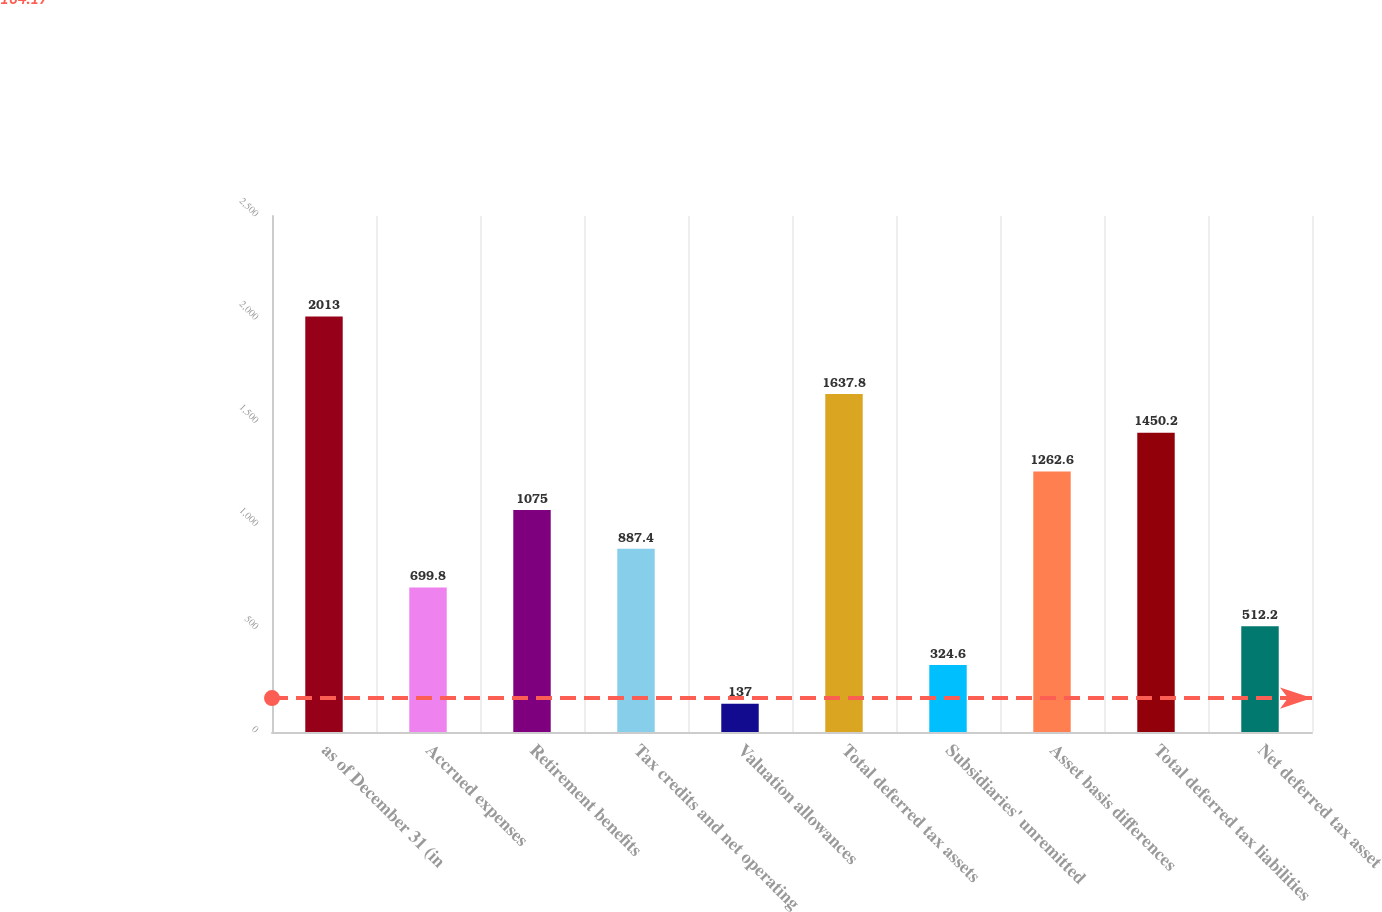<chart> <loc_0><loc_0><loc_500><loc_500><bar_chart><fcel>as of December 31 (in<fcel>Accrued expenses<fcel>Retirement benefits<fcel>Tax credits and net operating<fcel>Valuation allowances<fcel>Total deferred tax assets<fcel>Subsidiaries' unremitted<fcel>Asset basis differences<fcel>Total deferred tax liabilities<fcel>Net deferred tax asset<nl><fcel>2013<fcel>699.8<fcel>1075<fcel>887.4<fcel>137<fcel>1637.8<fcel>324.6<fcel>1262.6<fcel>1450.2<fcel>512.2<nl></chart> 